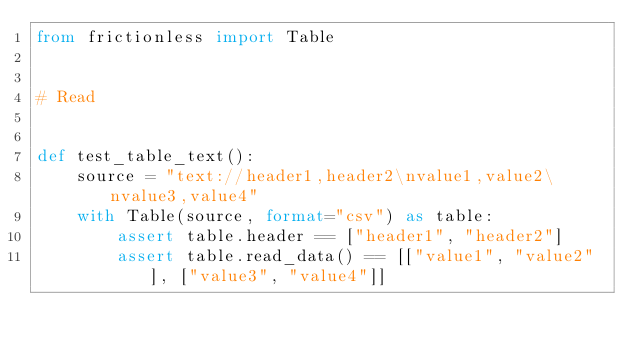Convert code to text. <code><loc_0><loc_0><loc_500><loc_500><_Python_>from frictionless import Table


# Read


def test_table_text():
    source = "text://header1,header2\nvalue1,value2\nvalue3,value4"
    with Table(source, format="csv") as table:
        assert table.header == ["header1", "header2"]
        assert table.read_data() == [["value1", "value2"], ["value3", "value4"]]
</code> 